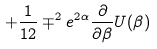Convert formula to latex. <formula><loc_0><loc_0><loc_500><loc_500>+ \frac { 1 } { 1 2 } \mp ^ { 2 } e ^ { 2 \alpha } \frac { \partial } { \partial \beta } U ( \beta )</formula> 